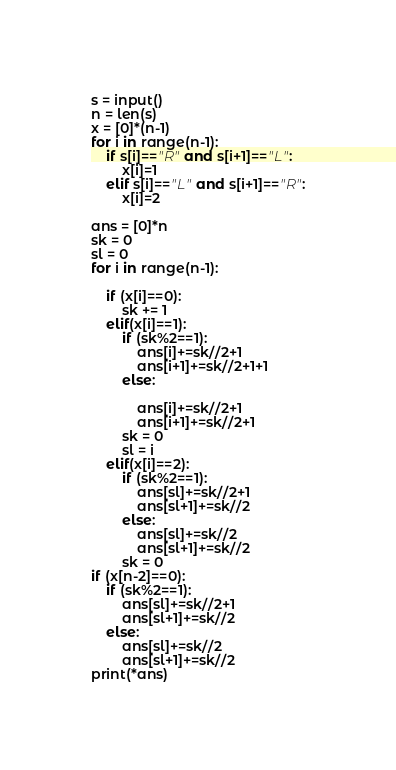<code> <loc_0><loc_0><loc_500><loc_500><_Python_>s = input()
n = len(s)
x = [0]*(n-1)
for i in range(n-1):
    if s[i]=="R" and s[i+1]=="L":
        x[i]=1
    elif s[i]=="L" and s[i+1]=="R":
        x[i]=2

ans = [0]*n
sk = 0
sl = 0
for i in range(n-1):
    
    if (x[i]==0):
        sk += 1
    elif(x[i]==1):
        if (sk%2==1):
            ans[i]+=sk//2+1
            ans[i+1]+=sk//2+1+1
        else:
            
            ans[i]+=sk//2+1
            ans[i+1]+=sk//2+1
        sk = 0
        sl = i
    elif(x[i]==2):
        if (sk%2==1):
            ans[sl]+=sk//2+1
            ans[sl+1]+=sk//2
        else:
            ans[sl]+=sk//2
            ans[sl+1]+=sk//2
        sk = 0
if (x[n-2]==0):
    if (sk%2==1):
        ans[sl]+=sk//2+1
        ans[sl+1]+=sk//2
    else:
        ans[sl]+=sk//2
        ans[sl+1]+=sk//2
print(*ans)</code> 